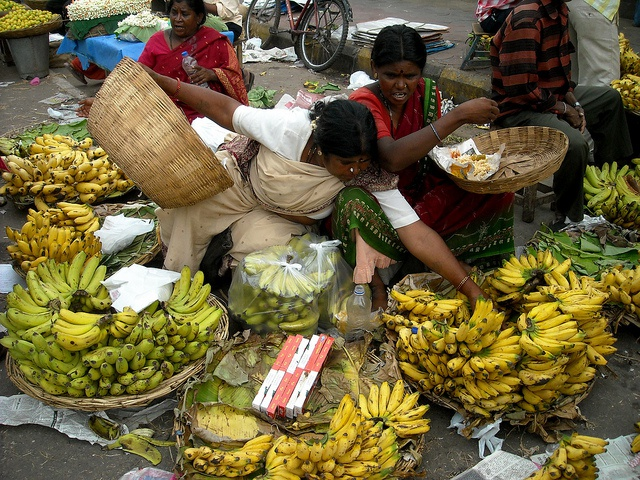Describe the objects in this image and their specific colors. I can see banana in olive and black tones, people in olive, black, tan, gray, and lightgray tones, people in olive, black, maroon, and gray tones, people in olive, black, maroon, and gray tones, and people in olive, maroon, black, brown, and gray tones in this image. 